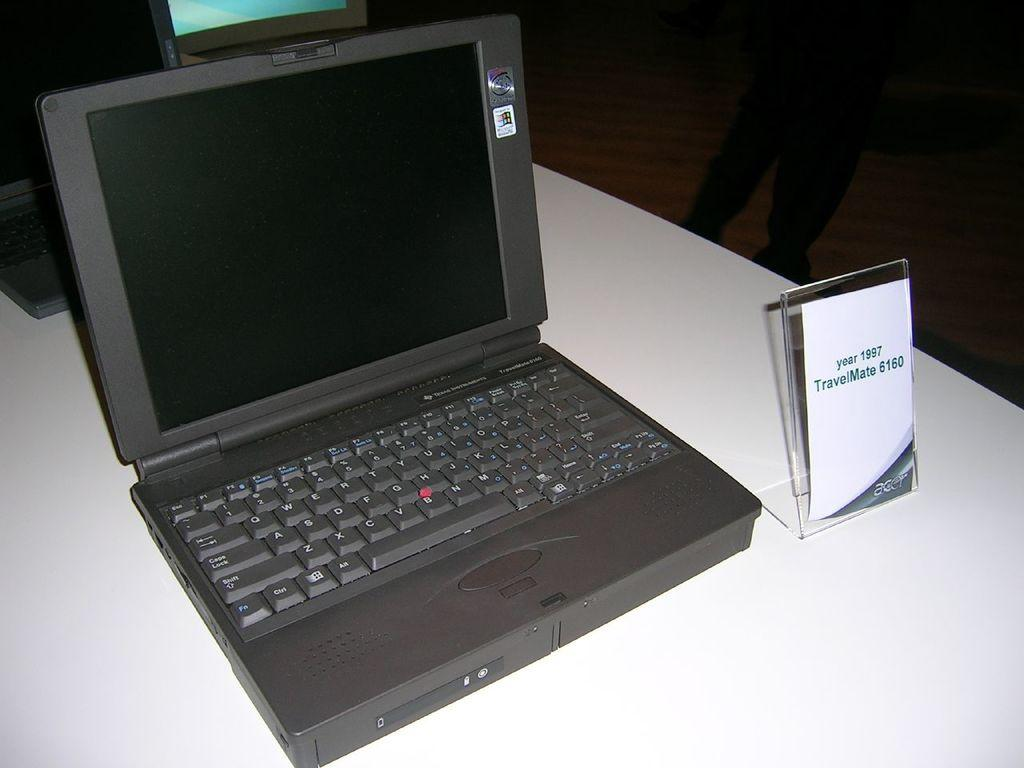<image>
Summarize the visual content of the image. the number 6160 is on a white piece of paper 